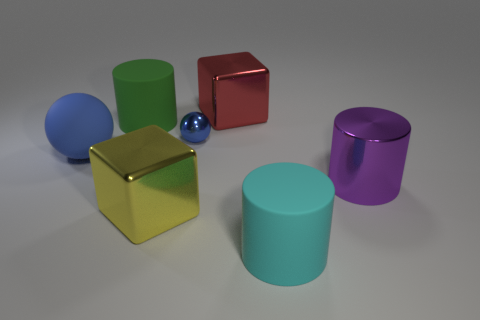Subtract all yellow cylinders. Subtract all brown cubes. How many cylinders are left? 3 Add 2 red metallic blocks. How many objects exist? 9 Subtract all cylinders. How many objects are left? 4 Subtract 0 blue cylinders. How many objects are left? 7 Subtract all large cyan cylinders. Subtract all red metal objects. How many objects are left? 5 Add 1 big purple things. How many big purple things are left? 2 Add 4 big green spheres. How many big green spheres exist? 4 